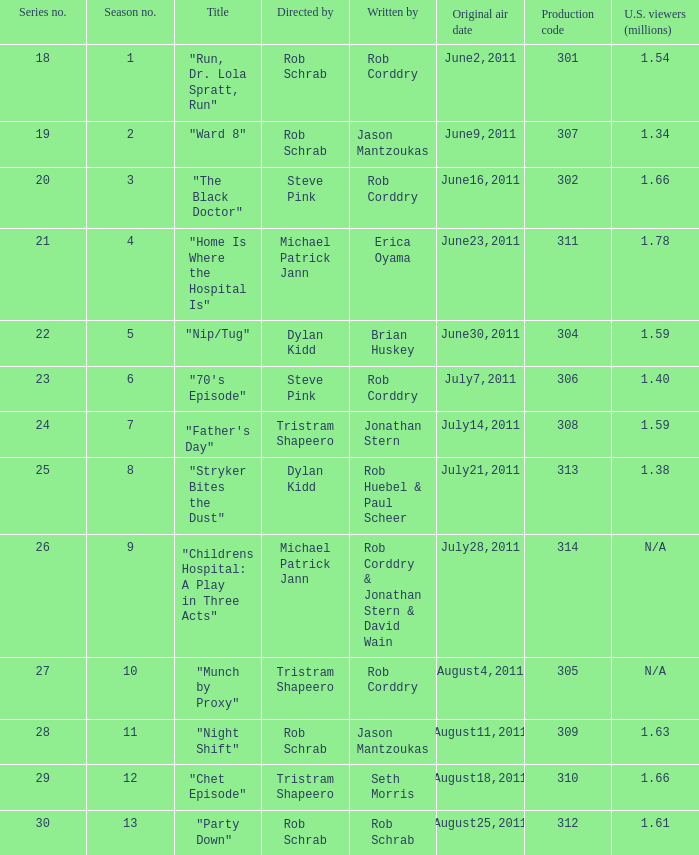Who directed the episode entitled "home is where the hospital is"? Michael Patrick Jann. 